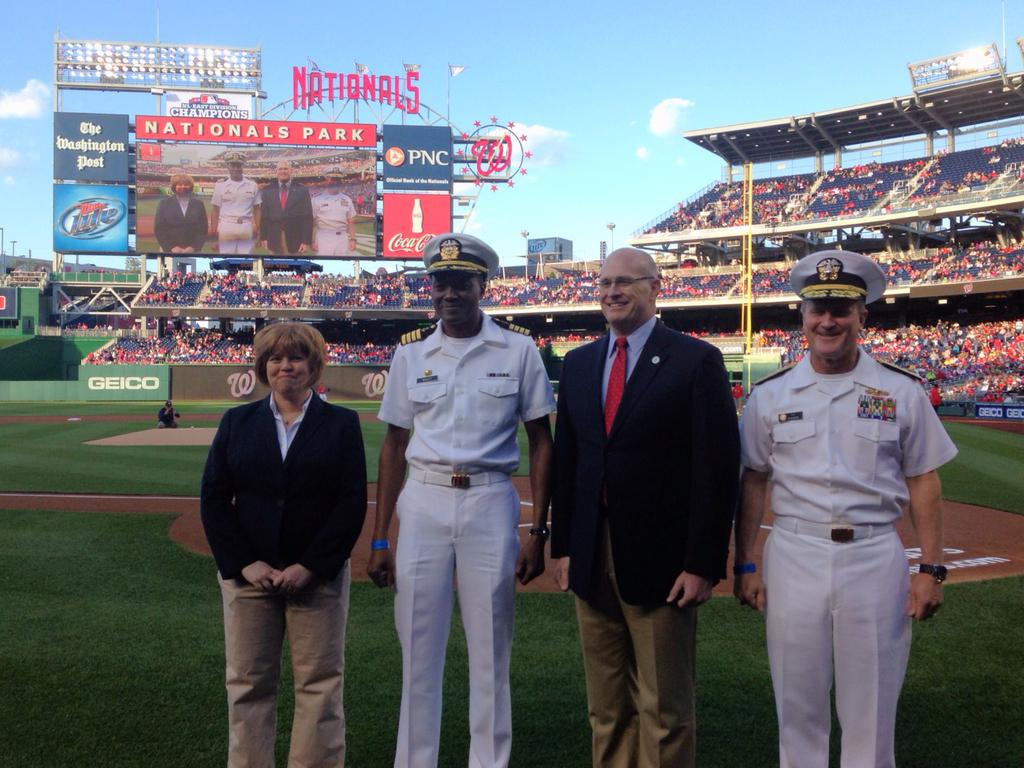Provide a one-sentence caption for the provided image. Four people stand on the field of Nationals Park. 